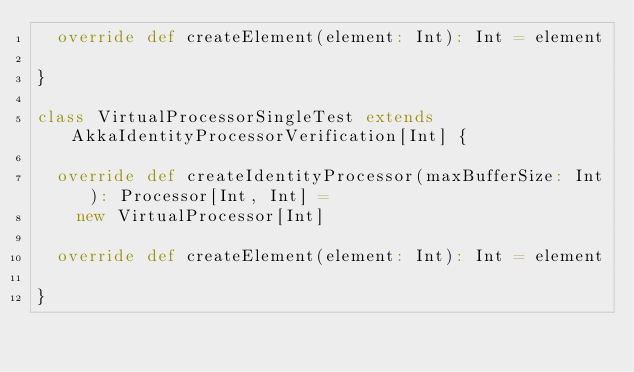<code> <loc_0><loc_0><loc_500><loc_500><_Scala_>  override def createElement(element: Int): Int = element

}

class VirtualProcessorSingleTest extends AkkaIdentityProcessorVerification[Int] {

  override def createIdentityProcessor(maxBufferSize: Int): Processor[Int, Int] =
    new VirtualProcessor[Int]

  override def createElement(element: Int): Int = element

}
</code> 